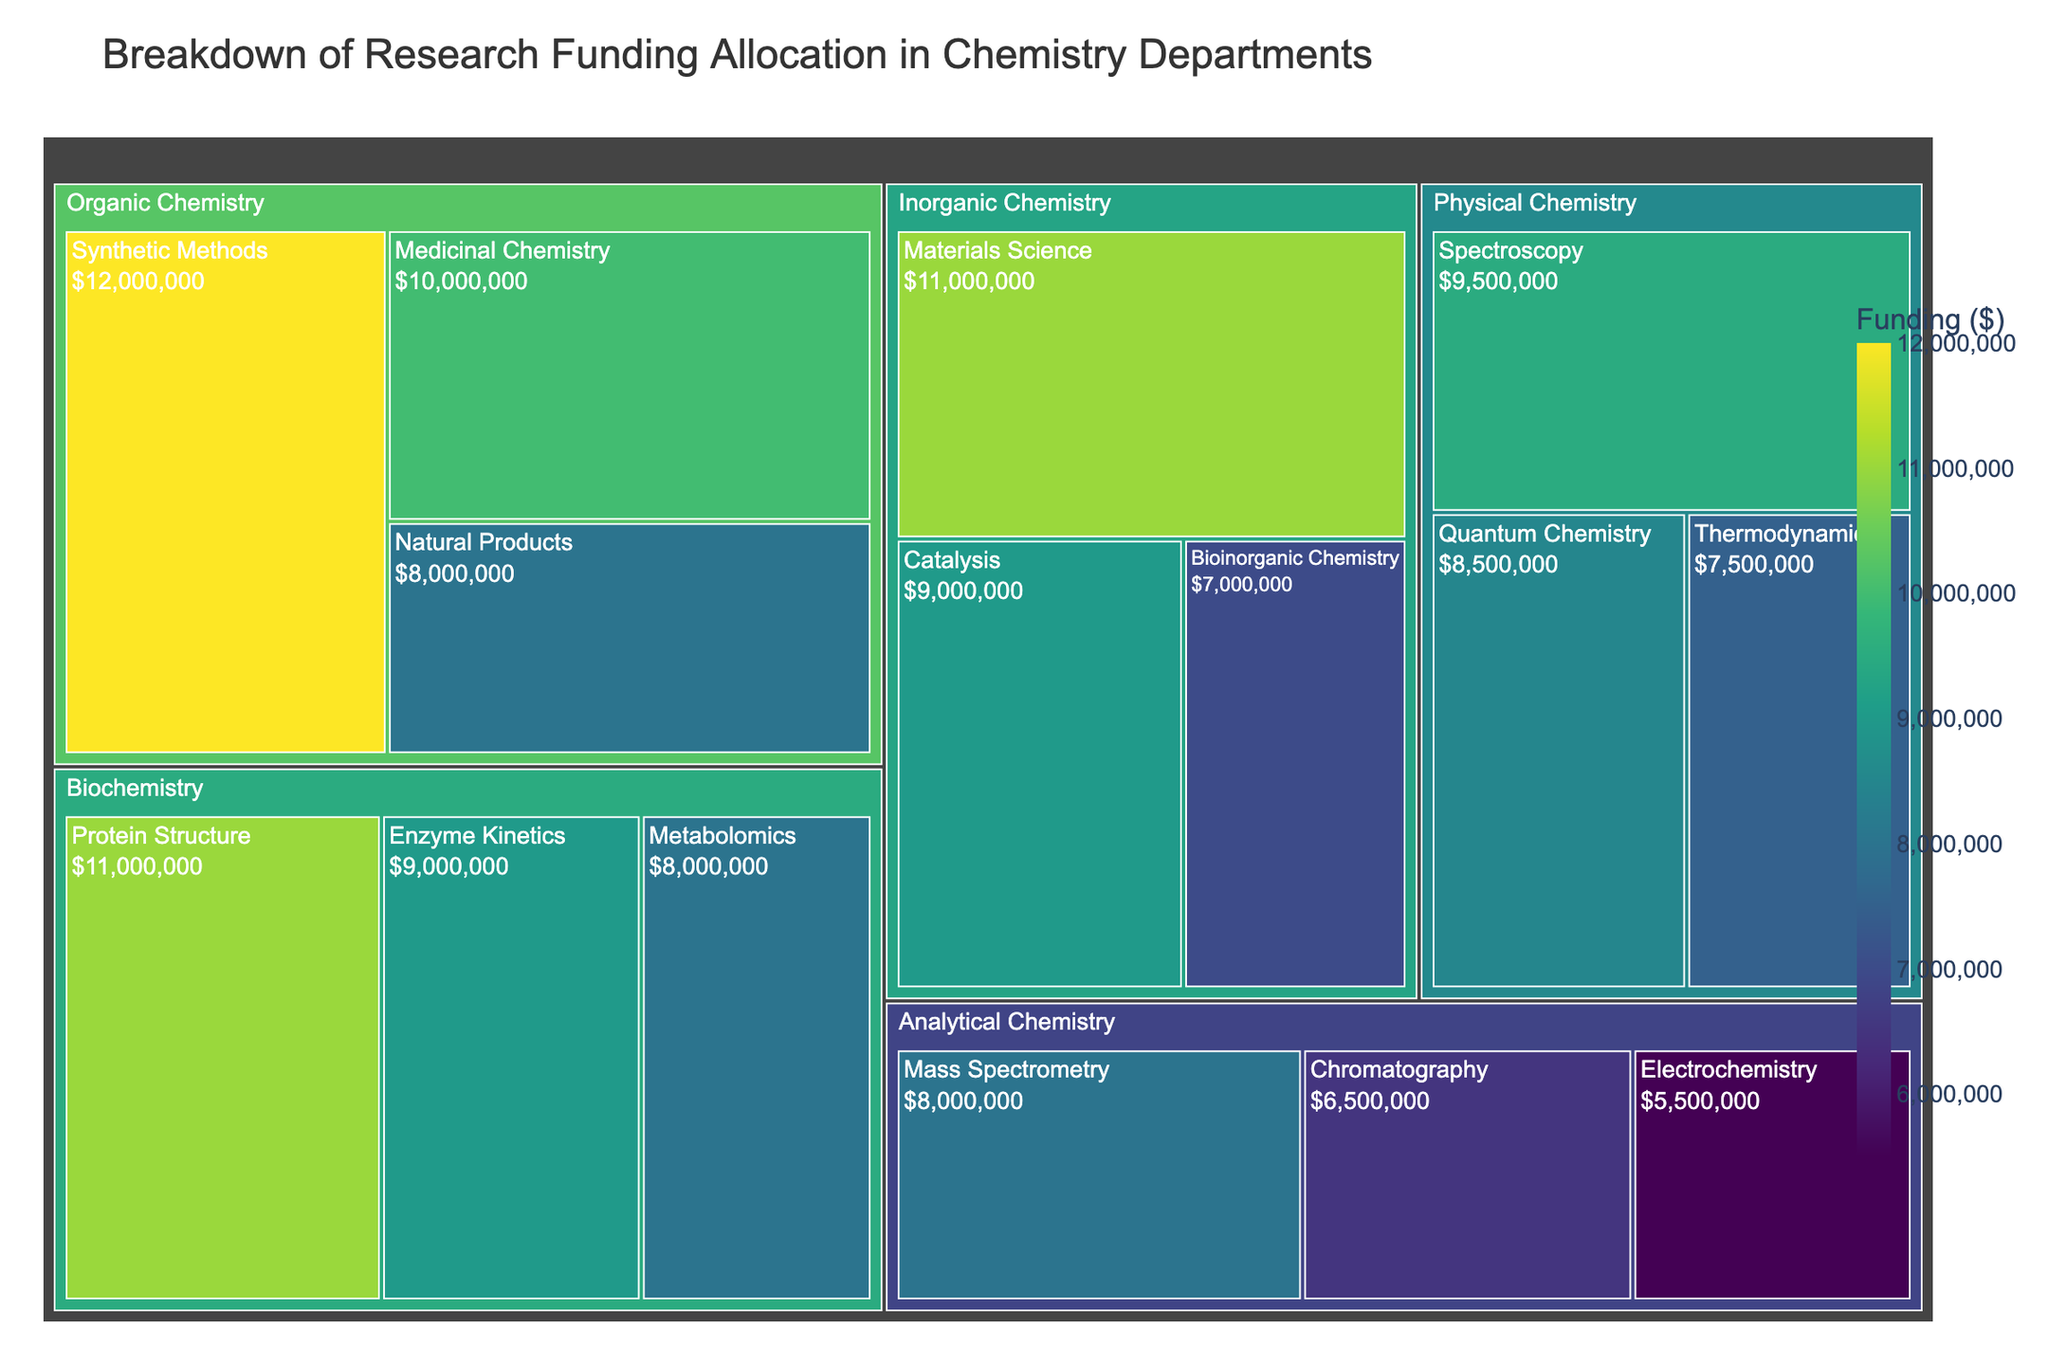What is the total funding allocated to Physical Chemistry? To find the total funding for Physical Chemistry, sum the values for its subcategories: Spectroscopy ($9,500,000), Quantum Chemistry ($8,500,000), and Thermodynamics ($7,500,000). The total is $9,500,000 + $8,500,000 + $7,500,000 = $25,500,000.
Answer: $25,500,000 Which subcategory in Organic Chemistry received the highest funding? Compare the funding values of all subcategories under Organic Chemistry: Synthetic Methods ($12,000,000), Natural Products ($8,000,000), and Medicinal Chemistry ($10,000,000). Synthetic Methods has the highest funding.
Answer: Synthetic Methods How does the funding for Catalysis compare to that for Materials Science under Inorganic Chemistry? Catalysis received $9,000,000 and Materials Science received $11,000,000. By comparing these values, Catalysis received less funding than Materials Science.
Answer: Materials Science > Catalysis What is the combined funding for all subcategories under Analytical Chemistry? Sum the funding for each subcategory in Analytical Chemistry: Chromatography ($6,500,000), Mass Spectrometry ($8,000,000), and Electrochemistry ($5,500,000). The total is $6,500,000 + $8,000,000 + $5,500,000 = $20,000,000.
Answer: $20,000,000 Which category received the highest overall funding? Sum the funding for all subcategories under each category: 
- Organic Chemistry: $12,000,000 (Synthetic Methods) + $8,000,000 (Natural Products) + $10,000,000 (Medicinal Chemistry) = $30,000,000
- Inorganic Chemistry: $9,000,000 (Catalysis) + $11,000,000 (Materials Science) + $7,000,000 (Bioinorganic Chemistry) = $27,000,000
- Physical Chemistry: $9,500,000 (Spectroscopy) + $8,500,000 (Quantum Chemistry) + $7,500,000 (Thermodynamics) = $25,500,000
- Analytical Chemistry: $6,500,000 (Chromatography) + $8,000,000 (Mass Spectrometry) + $5,500,000 (Electrochemistry) = $20,000,000
- Biochemistry: $11,000,000 (Protein Structure) + $9,000,000 (Enzyme Kinetics) + $8,000,000 (Metabolomics) = $28,000,000
Organic Chemistry has the highest funding with $30,000,000.
Answer: Organic Chemistry Which subcategory received the lowest funding overall and what is its value? Compare the funding value of each subcategory in all categories. The lowest value is for Electrochemistry under Analytical Chemistry with $5,500,000.
Answer: Electrochemistry, $5,500,000 How much more is the funding allocated to Protein Structure than to Metabolomics in Biochemistry? Subtract the funding for Metabolomics from the funding for Protein Structure: $11,000,000 - $8,000,000 = $3,000,000.
Answer: $3,000,000 What is the average funding for subcategories under Biochemistry? Sum the funding values for Protein Structure ($11,000,000), Enzyme Kinetics ($9,000,000), and Metabolomics ($8,000,000), then divide by the number of subcategories (3). The sum is $11,000,000 + $9,000,000 + $8,000,000 = $28,000,000. The average is $28,000,000 / 3 = $9,333,333.33.
Answer: $9,333,333.33 